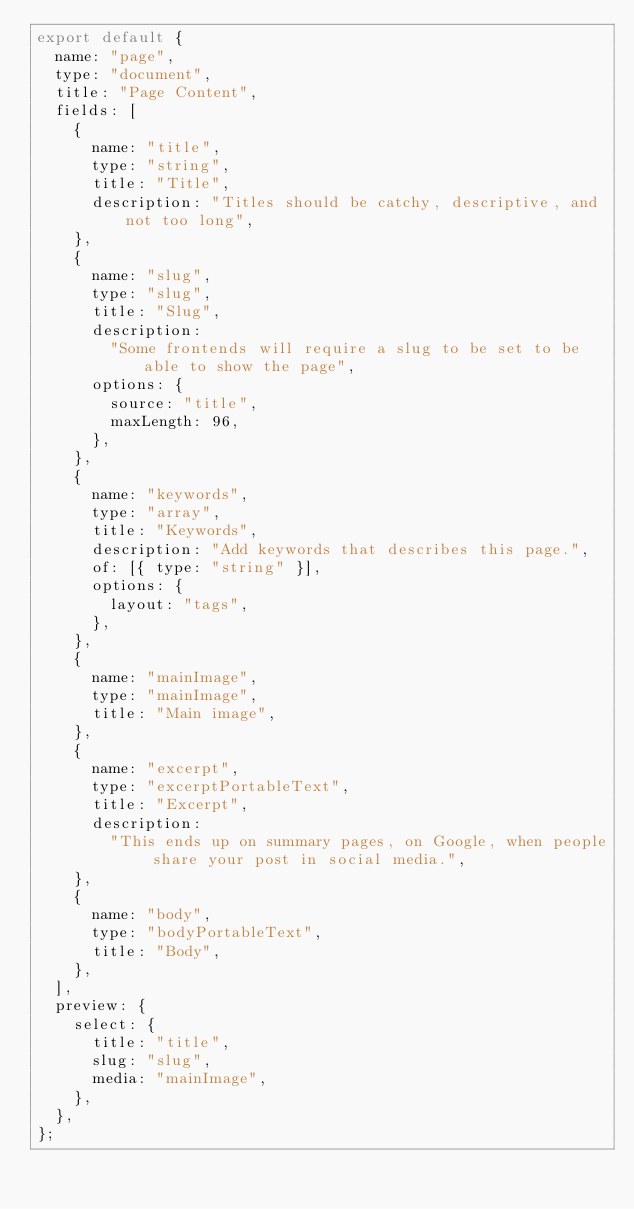<code> <loc_0><loc_0><loc_500><loc_500><_JavaScript_>export default {
  name: "page",
  type: "document",
  title: "Page Content",
  fields: [
    {
      name: "title",
      type: "string",
      title: "Title",
      description: "Titles should be catchy, descriptive, and not too long",
    },
    {
      name: "slug",
      type: "slug",
      title: "Slug",
      description:
        "Some frontends will require a slug to be set to be able to show the page",
      options: {
        source: "title",
        maxLength: 96,
      },
    },
    {
      name: "keywords",
      type: "array",
      title: "Keywords",
      description: "Add keywords that describes this page.",
      of: [{ type: "string" }],
      options: {
        layout: "tags",
      },
    },
    {
      name: "mainImage",
      type: "mainImage",
      title: "Main image",
    },
    {
      name: "excerpt",
      type: "excerptPortableText",
      title: "Excerpt",
      description:
        "This ends up on summary pages, on Google, when people share your post in social media.",
    },
    {
      name: "body",
      type: "bodyPortableText",
      title: "Body",
    },
  ],
  preview: {
    select: {
      title: "title",
      slug: "slug",
      media: "mainImage",
    },
  },
};
</code> 